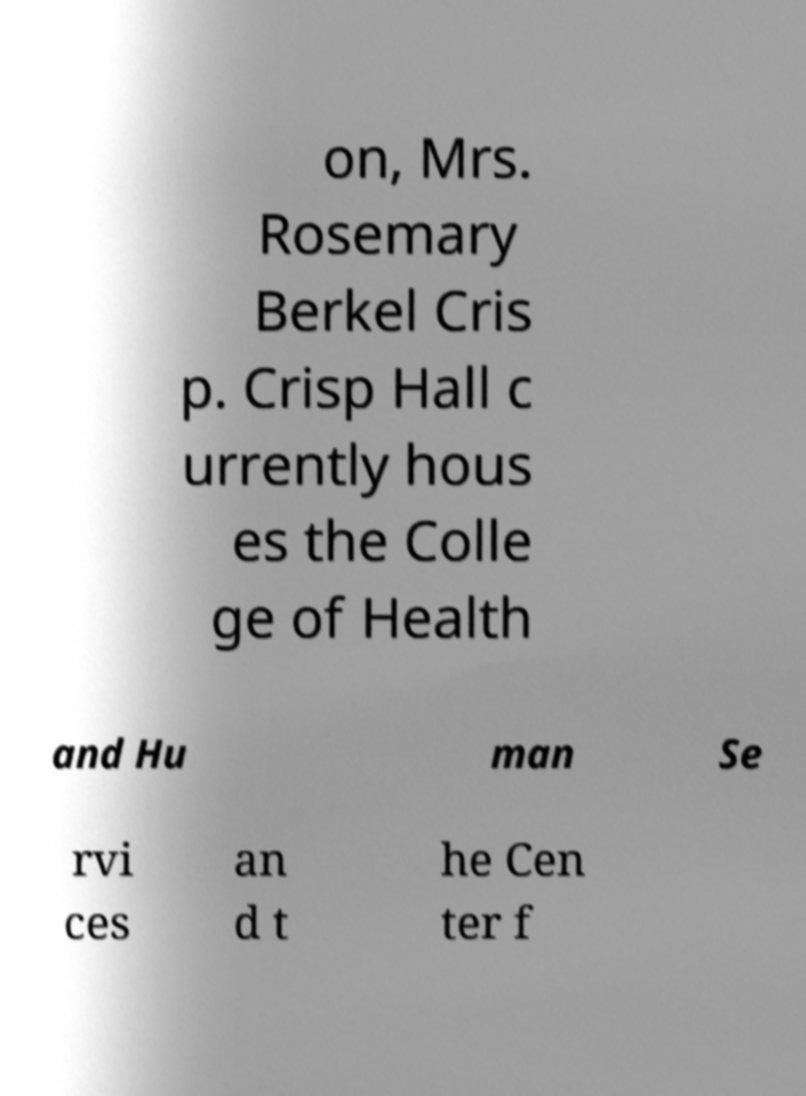Could you extract and type out the text from this image? on, Mrs. Rosemary Berkel Cris p. Crisp Hall c urrently hous es the Colle ge of Health and Hu man Se rvi ces an d t he Cen ter f 